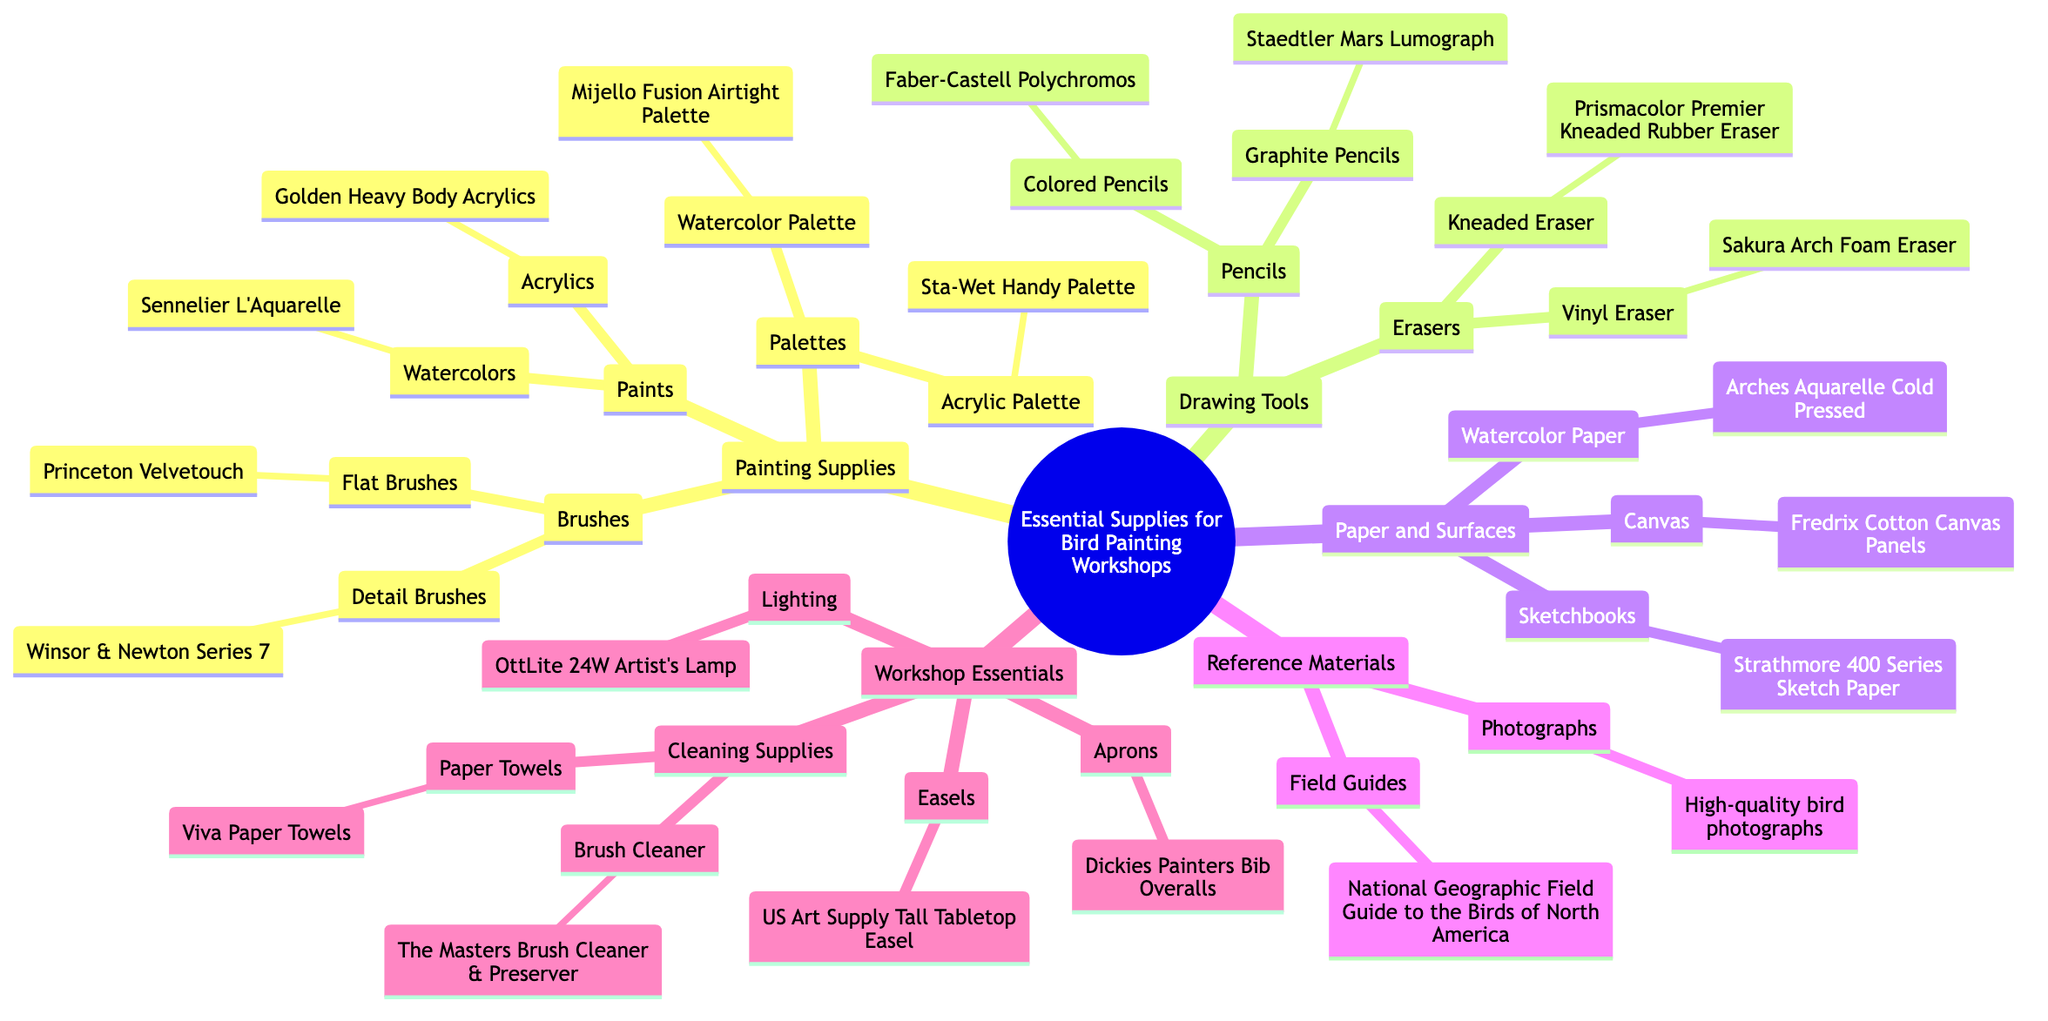What type of brushes are included in Painting Supplies? The diagram lists two types of brushes under Painting Supplies: Detail Brushes and Flat Brushes. It specifies examples for each category, which are Winsor & Newton Series 7 for Detail Brushes and Princeton Velvetouch for Flat Brushes.
Answer: Detail and Flat Brushes How many types of Pencils are mentioned in Drawing Tools? In the Drawing Tools section, there are two types of pencils: Graphite Pencils and Colored Pencils. This means that the count of different pencil types is two.
Answer: 2 Which brand of watercolors is recommended? In the Painting Supplies under Paints, the type for Watercolors is listed as Sennelier L'Aquarelle, making it the recommended brand for that category.
Answer: Sennelier L'Aquarelle What is the purpose of the item listed under Cleaning Supplies? The Cleaning Supplies section includes items like Brush Cleaner and Paper Towels. The Brush Cleaner is specifically meant for cleaning paintbrushes, while Paper Towels can be used for cleaning and absorbing paint spills. This indicates that both items serve to maintain cleanliness during painting.
Answer: Cleaning Which easel is recommended for workshops? Under Workshop Essentials, the specific easel recommended is the US Art Supply Tall Tabletop Easel, indicating this is the preferred choice for setting up during workshops.
Answer: US Art Supply Tall Tabletop Easel What types of paper are mentioned in Paper and Surfaces? The Paper and Surfaces section includes three types of paper: Watercolor Paper, Canvas, and Sketchbooks. Each category specifies a particular product, but the question here focuses on the presence of these categories rather than their specific products.
Answer: Watercolor Paper, Canvas, Sketchbooks Which materials are suggested for reference? Reference Materials in the diagram suggest Field Guides and Photographs as essential references. Specifically, it mentions the National Geographic Field Guide to the Birds of North America as a field guide.
Answer: Field Guides and Photographs How many main categories are identified in the diagram? The primary sections identified in the diagram are Painting Supplies, Drawing Tools, Paper and Surfaces, Reference Materials, and Workshop Essentials. Counting these, there are five main categories present in the mind map.
Answer: 5 What lighting product is mentioned under Workshop Essentials? The diagram lists OttLite 24W Artist's Lamp under the Workshop Essentials section, specifying the lighting product recommended for workshops.
Answer: OttLite 24W Artist's Lamp 